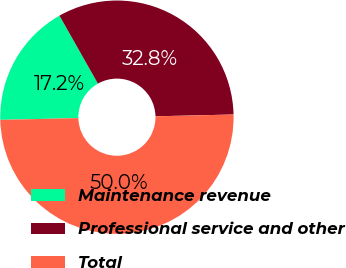Convert chart. <chart><loc_0><loc_0><loc_500><loc_500><pie_chart><fcel>Maintenance revenue<fcel>Professional service and other<fcel>Total<nl><fcel>17.17%<fcel>32.83%<fcel>50.0%<nl></chart> 